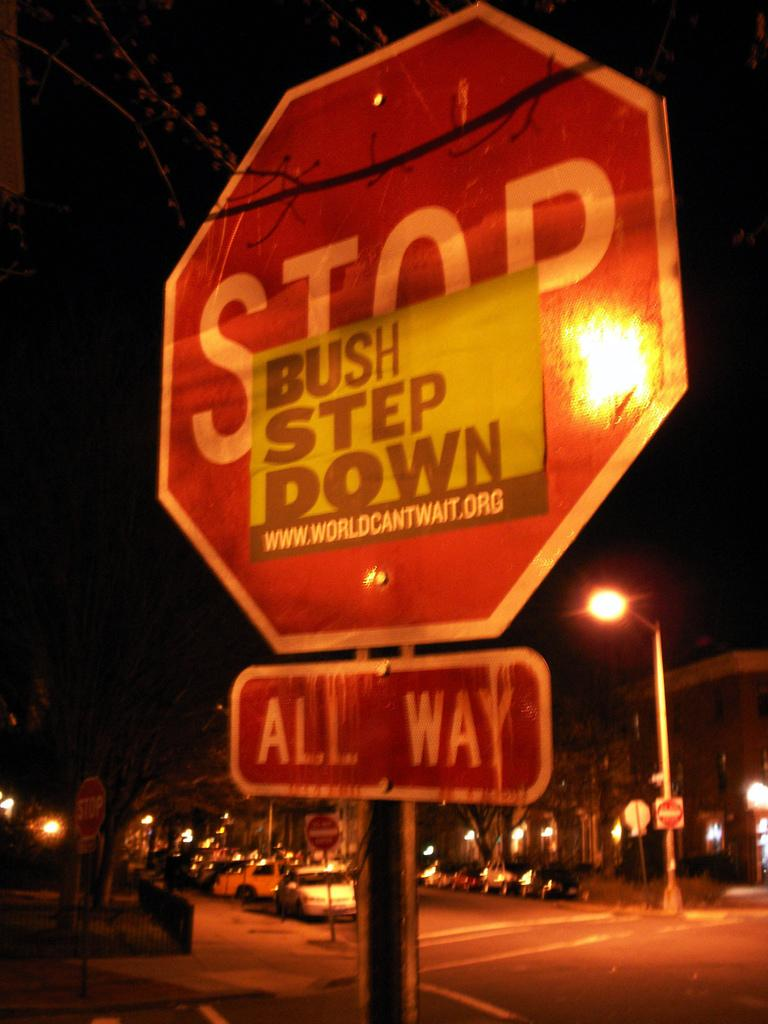<image>
Describe the image concisely. A red sigh has stop in white letters and all way under it. 